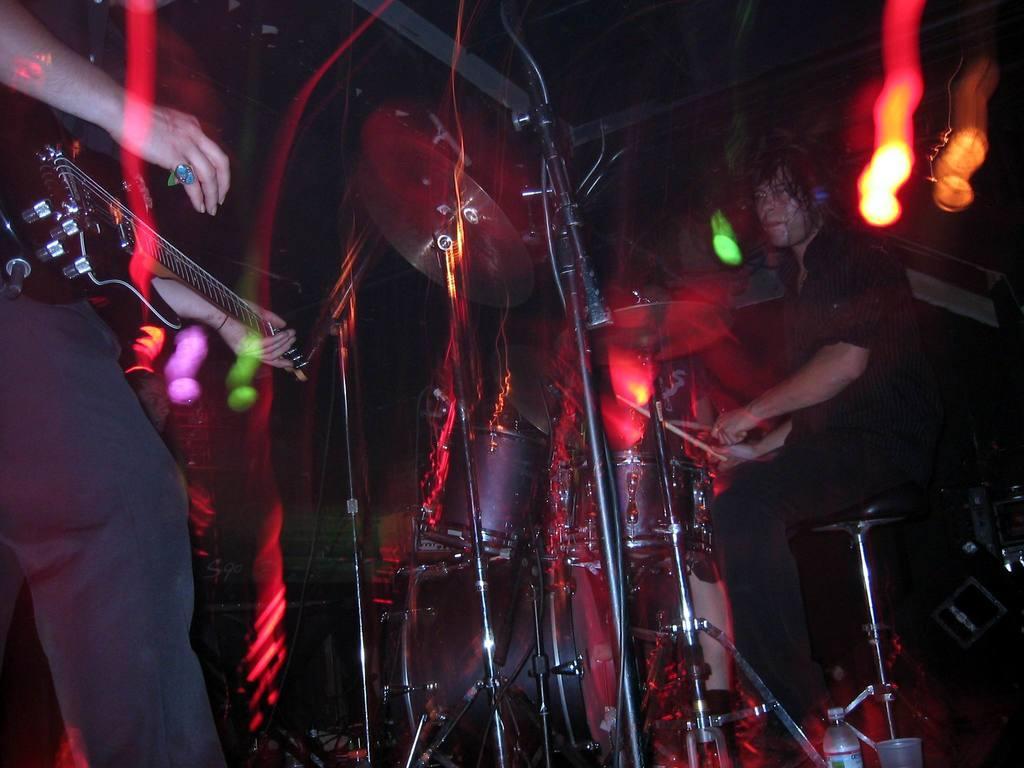Could you give a brief overview of what you see in this image? This is looking like a musical concert is going on. A man is playing guitar another man on the right is playing drums. On the top there are lights. On the right bottom there is bottle and glass. 